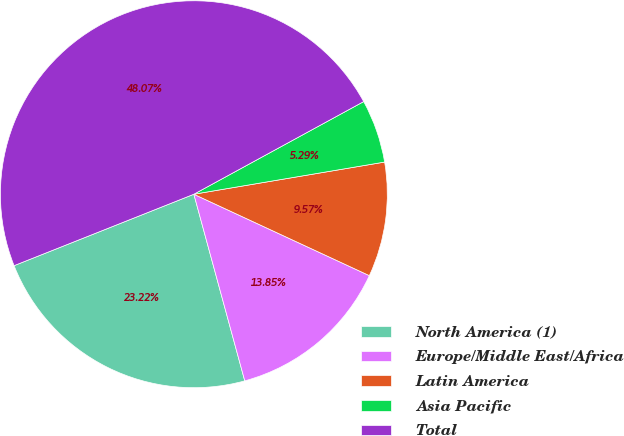Convert chart. <chart><loc_0><loc_0><loc_500><loc_500><pie_chart><fcel>North America (1)<fcel>Europe/Middle East/Africa<fcel>Latin America<fcel>Asia Pacific<fcel>Total<nl><fcel>23.22%<fcel>13.85%<fcel>9.57%<fcel>5.29%<fcel>48.07%<nl></chart> 